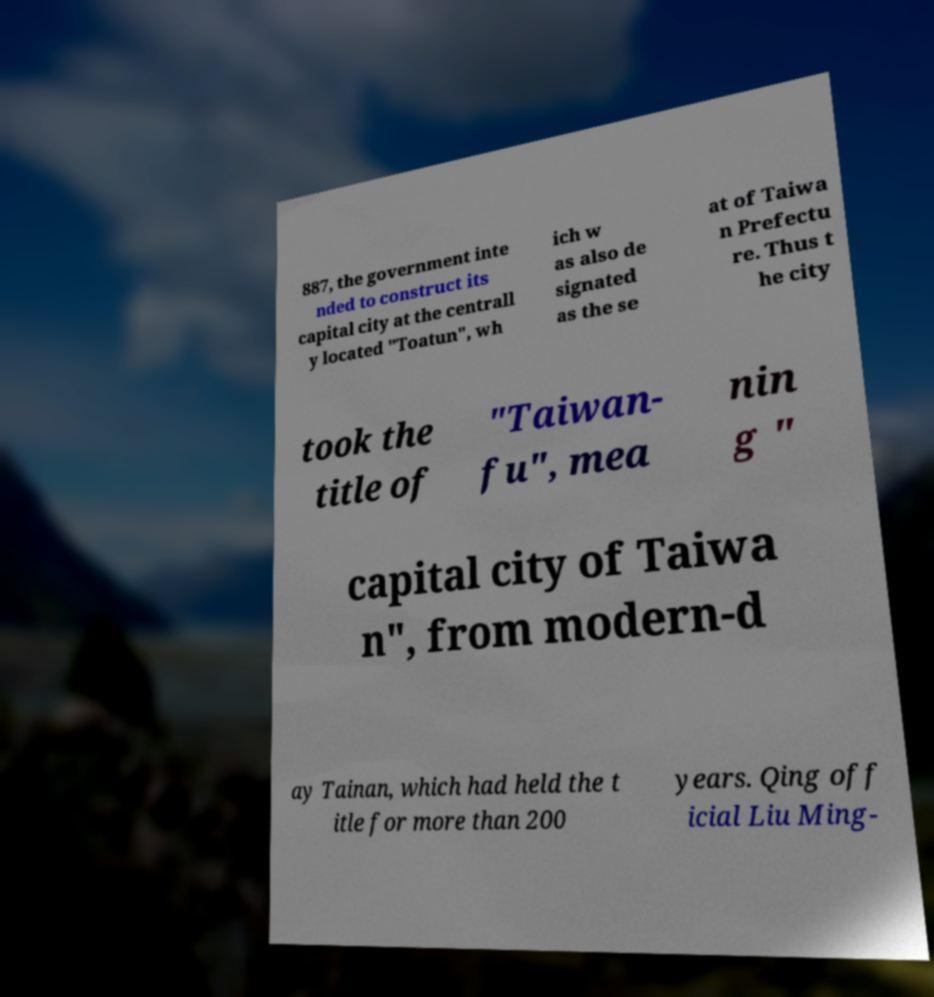Please read and relay the text visible in this image. What does it say? 887, the government inte nded to construct its capital city at the centrall y located "Toatun", wh ich w as also de signated as the se at of Taiwa n Prefectu re. Thus t he city took the title of "Taiwan- fu", mea nin g " capital city of Taiwa n", from modern-d ay Tainan, which had held the t itle for more than 200 years. Qing off icial Liu Ming- 